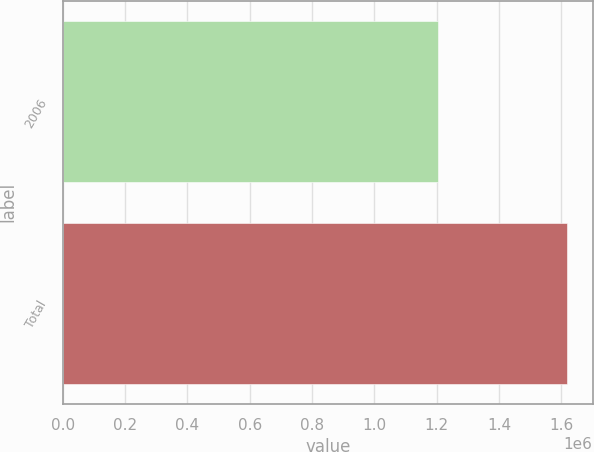<chart> <loc_0><loc_0><loc_500><loc_500><bar_chart><fcel>2006<fcel>Total<nl><fcel>1.20476e+06<fcel>1.61973e+06<nl></chart> 